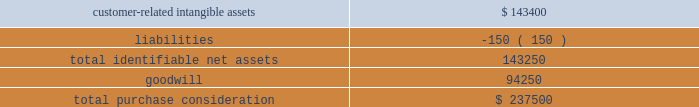Fis gaming business on june 1 , 2015 , we acquired certain assets of certegy check services , inc. , a wholly-owned subsidiary of fidelity national information services , inc .
( 201cfis 201d ) .
Under the purchase arrangement , we acquired substantially all of the assets of its gaming business related to licensed gaming operators ( the 201cfis gaming business 201d ) , including relationships with gaming clients in approximately 260 locations as of the acquisition date , for $ 237.5 million , funded from borrowings on our revolving credit facility and cash on hand .
We acquired the fis gaming business to expand our direct distribution and service offerings in the gaming market .
The estimated acquisition-date fair values of major classes of assets acquired and liabilities assumed , including a reconciliation to the total purchase consideration , were as follows ( in thousands ) : .
Goodwill arising from the acquisition , included in the north america segment , was attributable to an expected growth opportunities , including cross-selling opportunities at existing and acquired gaming client locations and operating synergies in the gaming business , and an assembled workforce .
Goodwill associated with this acquisition is deductible for income tax purposes .
The customer-related intangible assets have an estimated amortization period of 15 years .
Valuation of identified intangible assets for the acquisitions discussed above , the estimated fair values of customer-related intangible assets were determined using the income approach , which was based on projected cash flows discounted to their present value using discount rates that consider the timing and risk of the forecasted cash flows .
The discount rates used represented the average estimated value of a market participant 2019s cost of capital and debt , derived using customary market metrics .
Acquired technologies were valued using the replacement cost method , which required us to estimate the costs to construct an asset of equivalent utility at prices available at the time of the valuation analysis , with adjustments in value for physical deterioration and functional and economic obsolescence .
Trademarks and trade names were valued using the 201crelief-from-royalty 201d approach .
This method assumes that trademarks and trade names have value to the extent that their owner is relieved of the obligation to pay royalties for the benefits received from them .
This method required us to estimate the future revenues for the related brands , the appropriate royalty rate and the weighted-average cost of capital .
The discount rates used represented the average estimated value of a market participant 2019s cost of capital and debt , derived using customary market metrics .
Note 3 2014 revenues we are a leading worldwide provider of payment technology and software solutions delivering innovative services to our customers globally .
Our technologies , services and employee expertise enable us to provide a broad range of solutions that allow our customers to accept various payment types and operate their businesses more efficiently .
We distribute our services across a variety of channels to customers .
The disclosures in this note are applicable for the year ended december 31 , 2018 .
Global payments inc .
| 2018 form 10-k annual report 2013 79 .
What portion of the total purchase consideration is goodwill? 
Computations: (94250 / 237500)
Answer: 0.39684. 